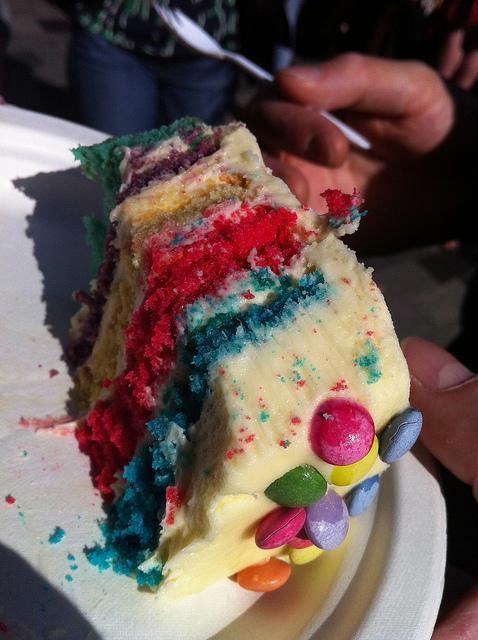How many human hands are in this picture?
Give a very brief answer. 2. How many layers are there?
Give a very brief answer. 5. How many slices are cut into the cake?
Give a very brief answer. 1. How many people are in the photo?
Give a very brief answer. 2. 